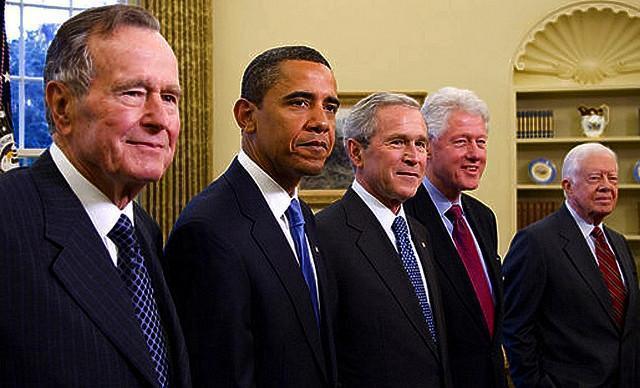Who is the second man from the left?
Choose the right answer and clarify with the format: 'Answer: answer
Rationale: rationale.'
Options: Barak obama, ronald reagan, ben franklin, george bush. Answer: barak obama.
Rationale: He is the first black and white president. What do these men have in common?
Select the accurate answer and provide justification: `Answer: choice
Rationale: srationale.`
Options: Chess players, sports team, presidency, corporate ownership. Answer: presidency.
Rationale: These men all are presidents. 